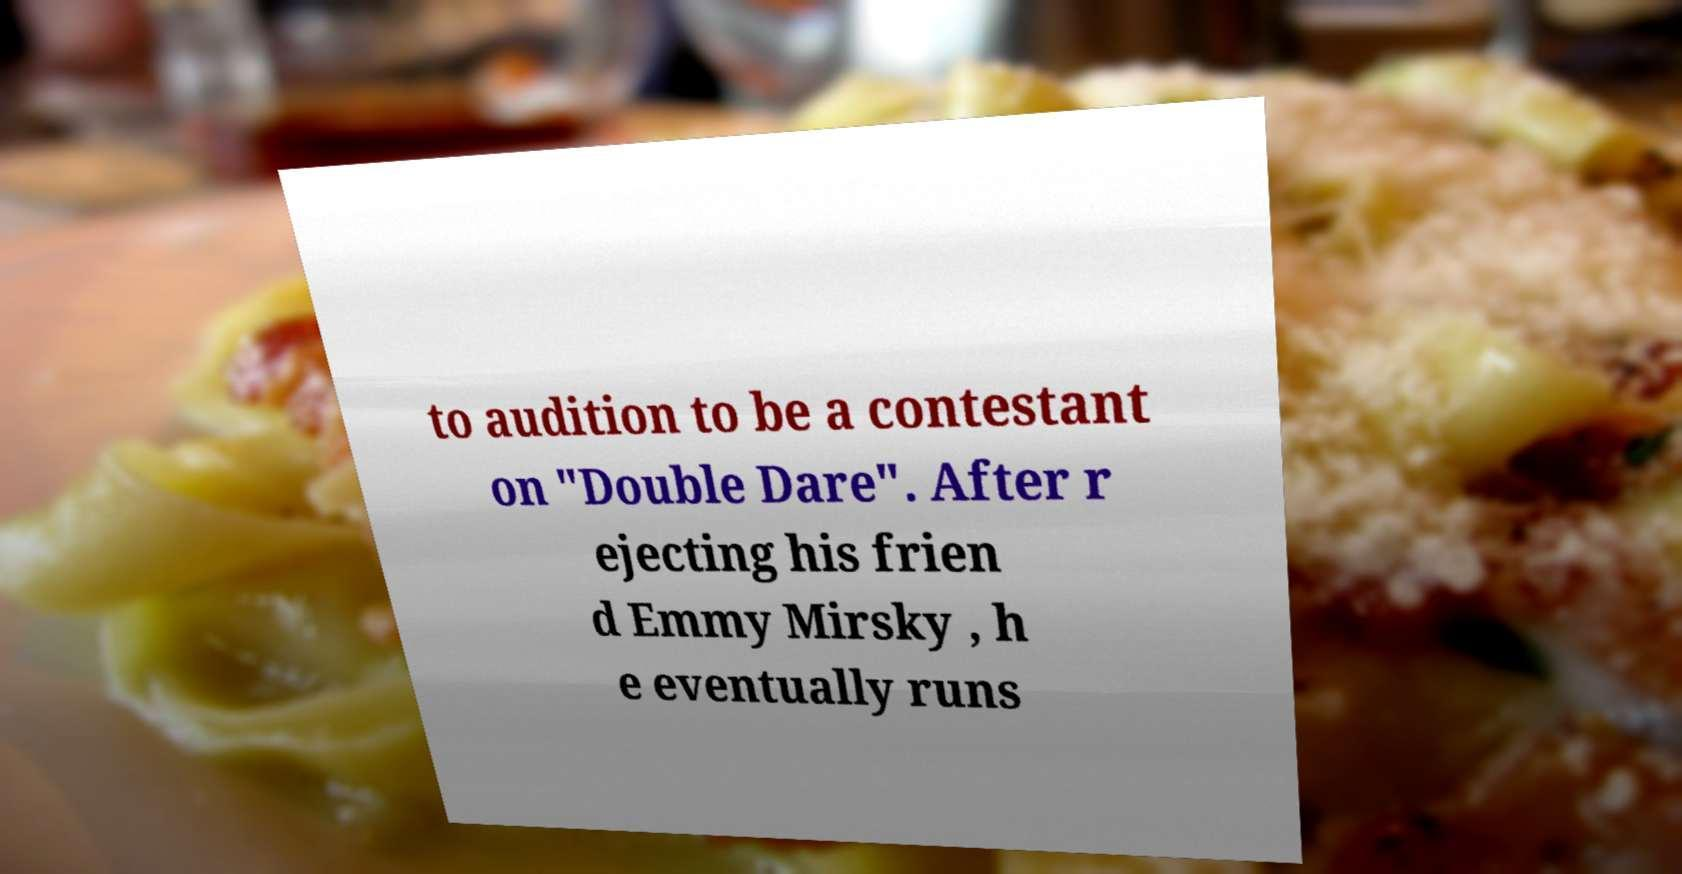What messages or text are displayed in this image? I need them in a readable, typed format. to audition to be a contestant on "Double Dare". After r ejecting his frien d Emmy Mirsky , h e eventually runs 